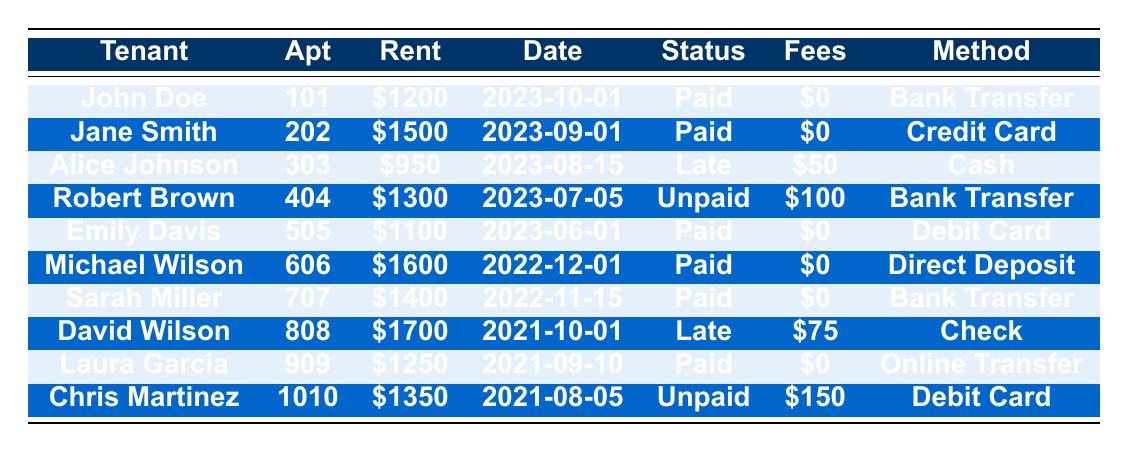What is the rent amount for John Doe? In the table, I can find John Doe in the row corresponding to his name. He is listed under the "Rent" column with an amount of $1200.
Answer: $1200 How many payments were marked as "Paid"? To find this, I look through the "Status" column and count how many entries say "Paid." There are five entries: John Doe, Jane Smith, Emily Davis, Michael Wilson, and Sarah Miller.
Answer: 5 What is the total amount of late fees accrued by all tenants? I can find the late fees for each tenant in the "Fees" column. The amounts are $50 (Alice Johnson), $100 (Robert Brown), $75 (David Wilson), and $150 (Chris Martinez). Adding these together gives $50 + $100 + $75 + $150 = $375.
Answer: $375 Was Robert Brown's rent payment paid on time? I can check the "Status" column for Robert Brown, where it states "Unpaid." Hence, it indicates his rent payment was not made on time.
Answer: No Which tenant had the highest rent amount, and what was that amount? I examine the "Rent" column to find the highest value. Michael Wilson has the highest rent amount listed as $1600.
Answer: $1600 How many tenants made their payments using a bank transfer? I will look at the "Method" column for entries that say "Bank Transfer." There are three tenants: John Doe, Robert Brown, and Sarah Miller.
Answer: 3 What is the average rent amount for all tenants on the list? First, I sum the rent amounts: $1200 + $1500 + $950 + $1300 + $1100 + $1600 + $1400 + $1700 + $1250 + $1350 = $13500. Then, I divide by the number of tenants, which is 10, giving an average of $13500/10 = $1350.
Answer: $1350 Which payment method was used by Alice Johnson, and what was her payment status? I look at Alice Johnson's row and find her payment method listed as "Cash" and her payment status as "Late."
Answer: Cash; Late Did any tenant pay their rent in the same month as they were due? I can cross-reference the "Payment Date" with the monthly timeline of each tenant. John Doe, Jane Smith, and Emily Davis made their payments in the month they were due, indicating they paid on time.
Answer: Yes Out of the tenants who paid late, which one had the highest rent, and how much was the late fee? The tenants who paid late are Alice Johnson, Robert Brown, and David Wilson. The highest rent among them is David Wilson, who had a late fee of $75.
Answer: David Wilson; $75 